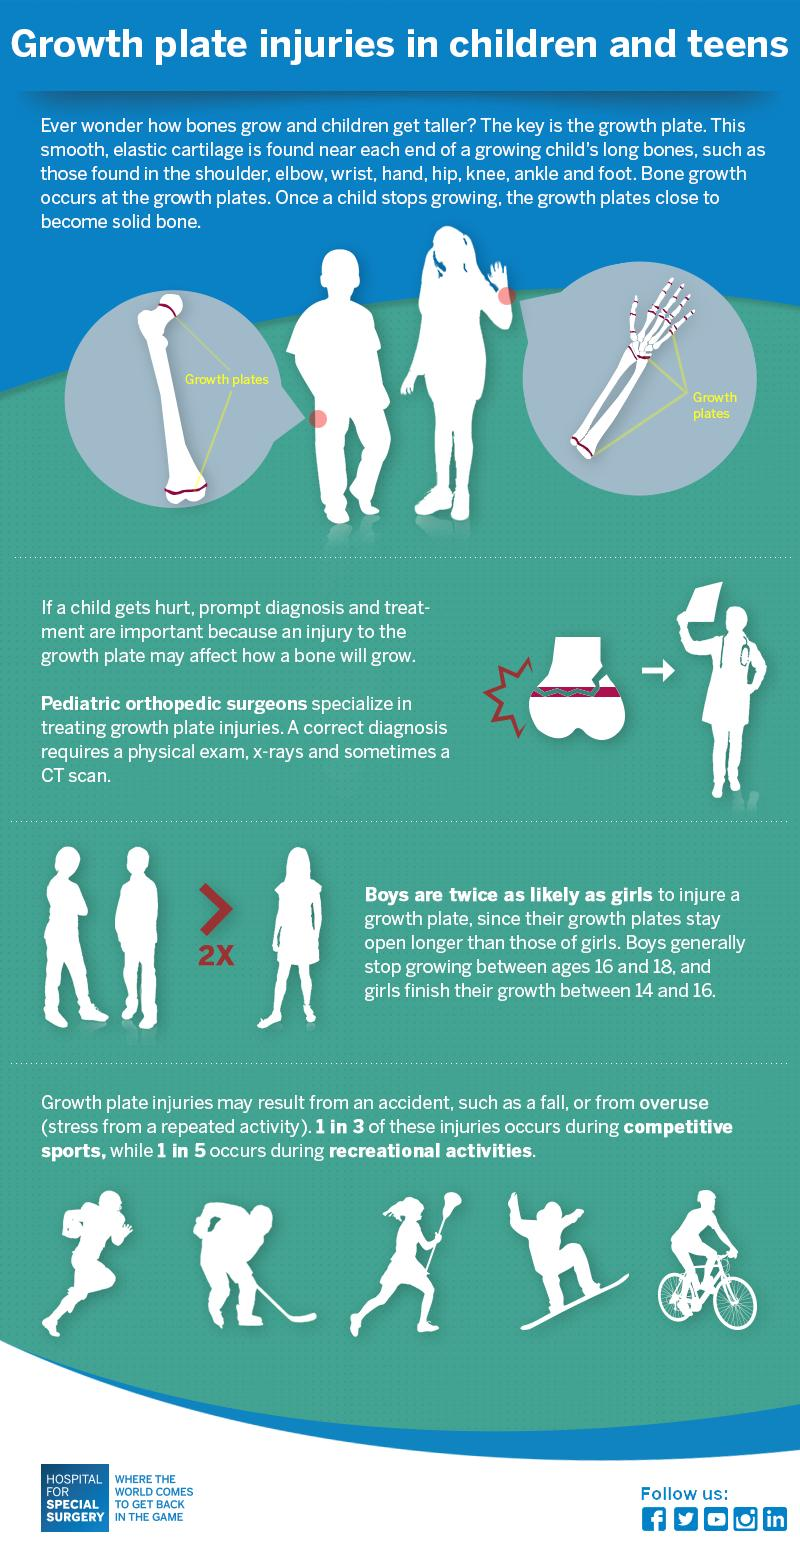Give some essential details in this illustration. There are a total of 8 male icons featured in this infographic. The color of the bicycle is red, white, or green. It is white. The color used to write "2x" in the infographic is red. There are three female icons included in this infographic. 